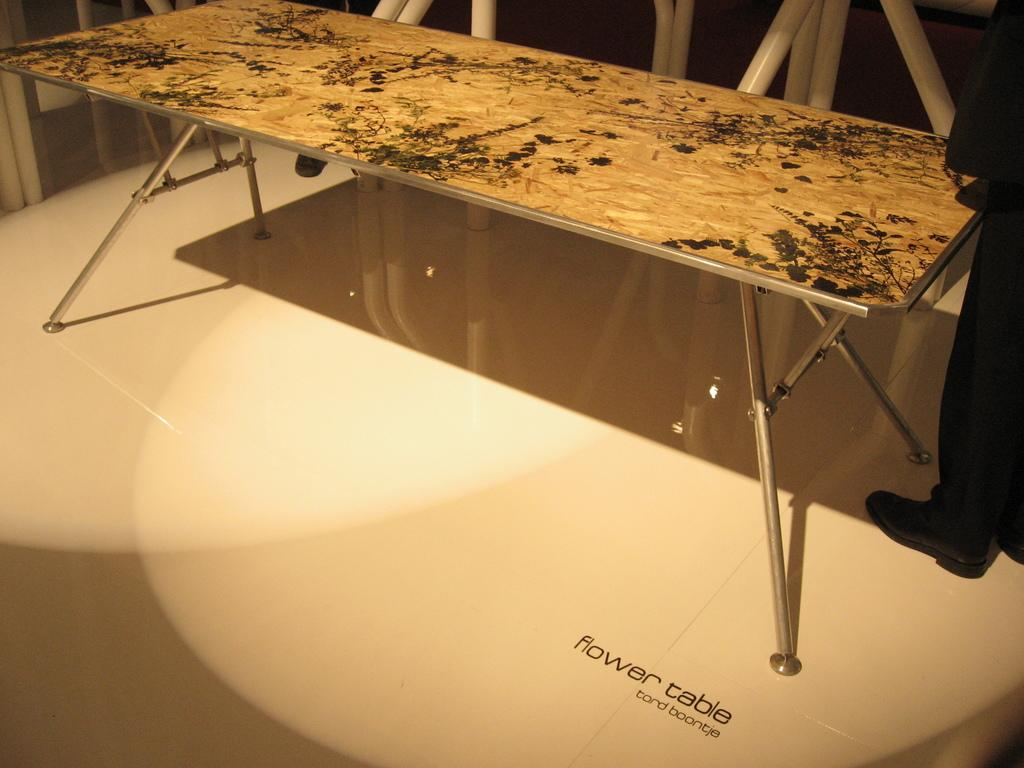What is the main object in the image? There is a table in the image. Is there anyone else in the image besides the table? Yes, there is a man standing in the right corner of the image. What is the man wearing on his feet? The man is wearing shoes. What type of jam is the man spreading on the table in the image? There is no jam present in the image, and the man is not interacting with the table in any way. 